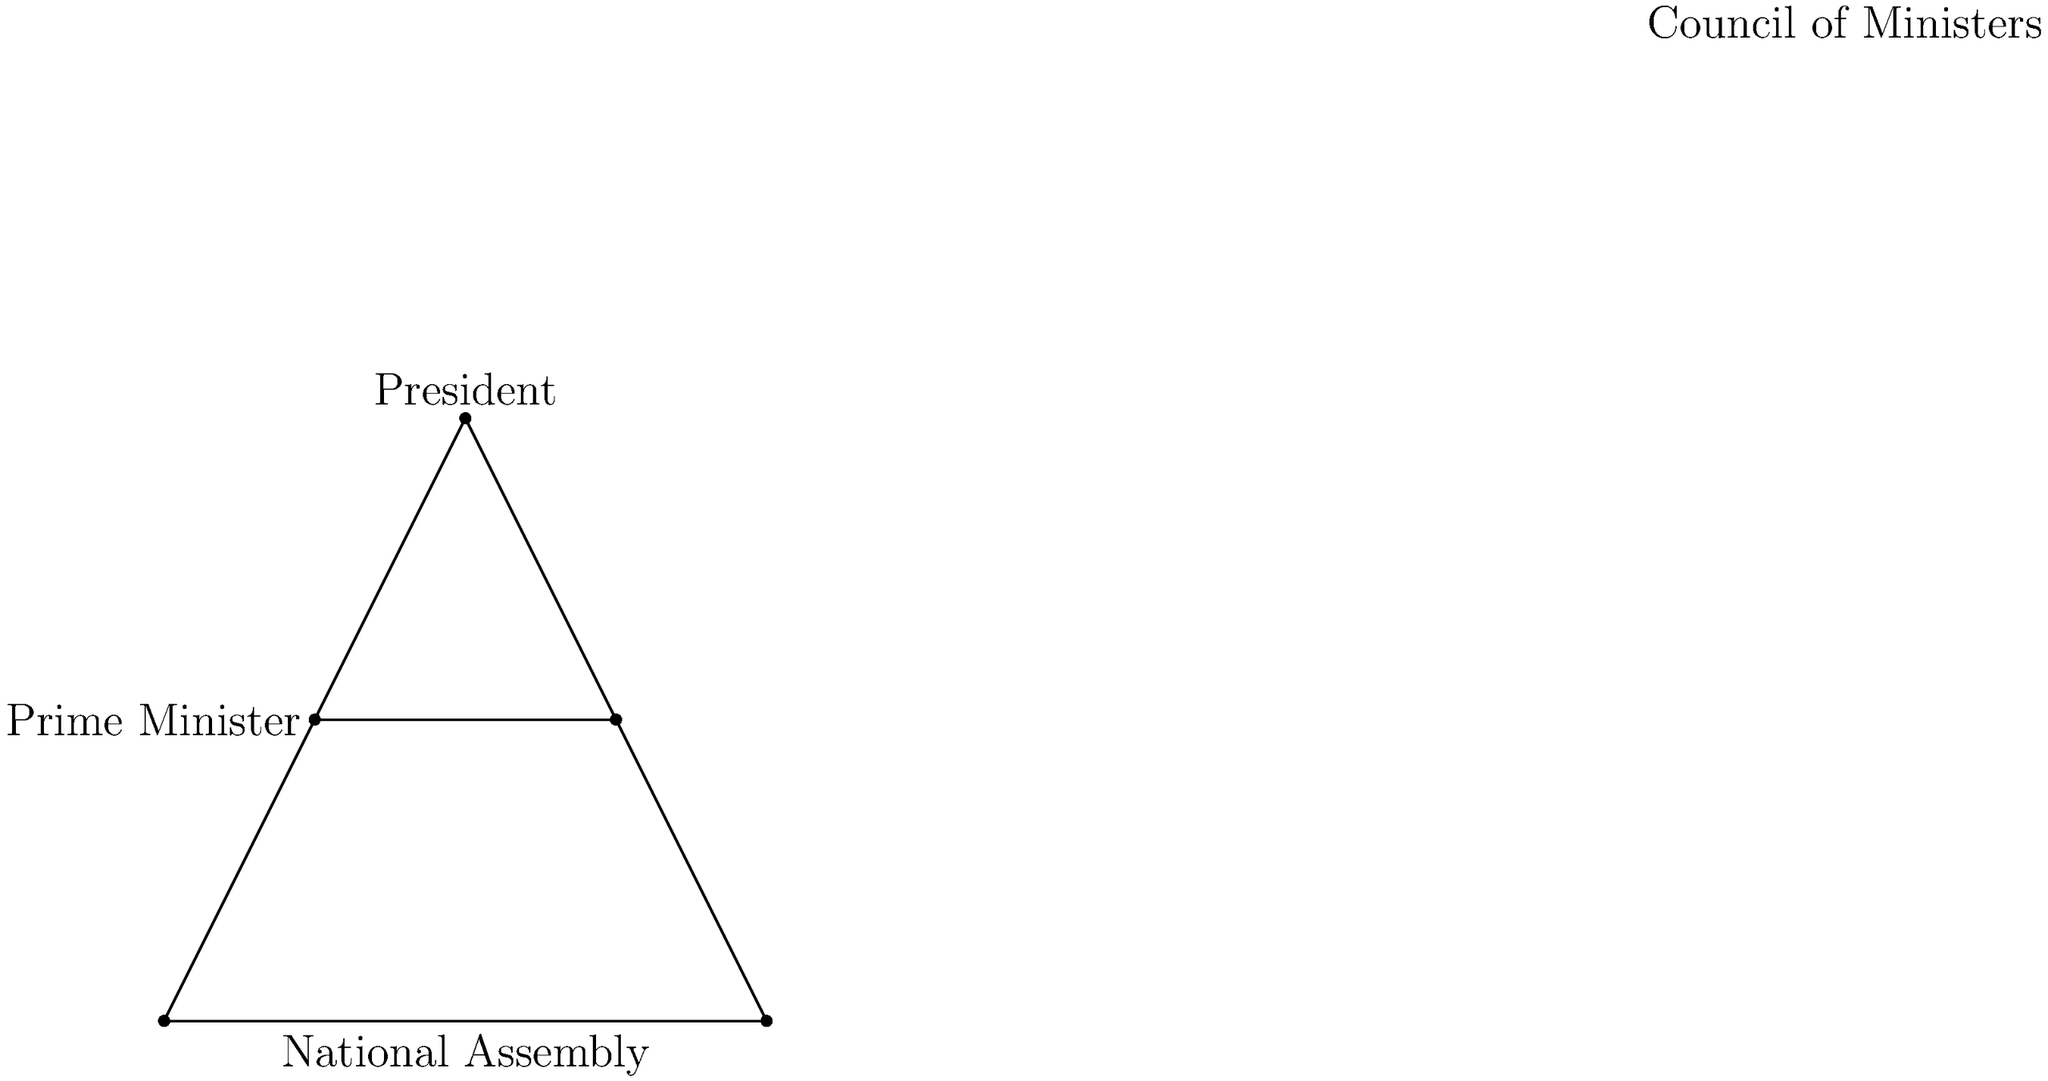Analyze the organizational structure depicted in the diagram. Which political regime in Benin's history does this structure most closely resemble, and what significant change occurred in this structure following the 1990 National Conference? 1. The diagram shows a pyramidal structure with the President at the top, indicating a strong executive power.

2. Below the President, we see a Prime Minister and a Council of Ministers, suggesting a semi-presidential system.

3. The National Assembly is represented at the base, indicating the legislative branch.

4. This structure most closely resembles the political regime of Benin during the early years of Mathieu Kérékou's presidency (1972-1990), particularly after the adoption of the 1977 constitution.

5. During this period, Benin (then known as the People's Republic of Benin) had a socialist-oriented government with a strong presidency.

6. The significant change that occurred following the 1990 National Conference was the removal of the position of Prime Minister.

7. The 1990 Constitution, which marked Benin's transition to a multi-party democracy, established a presidential system without a Prime Minister.

8. This change aimed to prevent potential conflicts between the President and Prime Minister, which had been observed in other African countries during democratic transitions.
Answer: Kérékou's regime (1972-1990); Prime Minister position removed post-1990. 